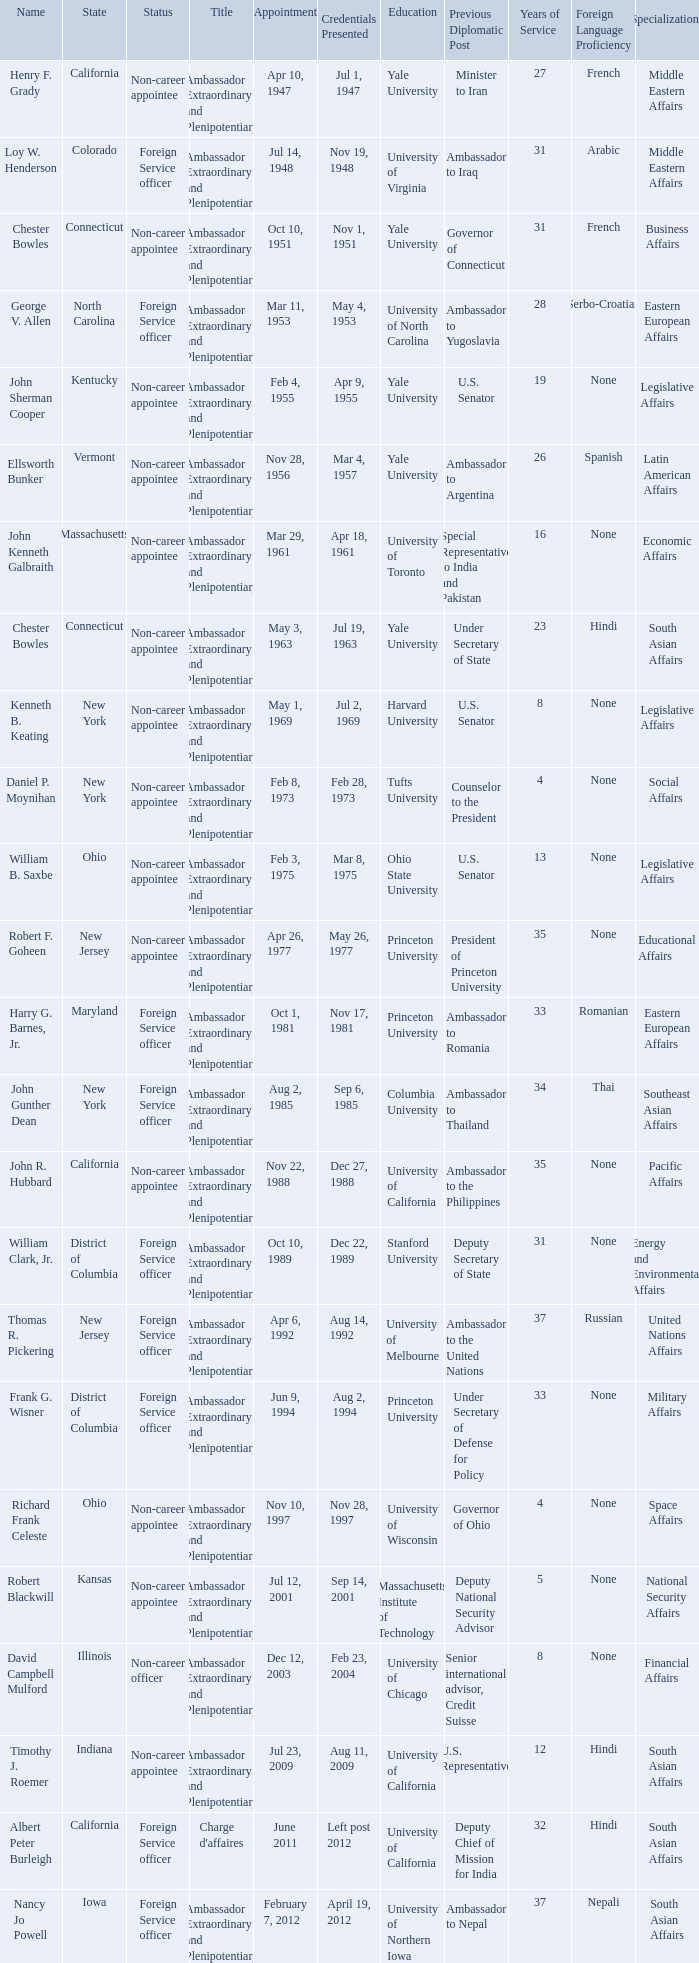What day were credentials presented for vermont? Mar 4, 1957. 